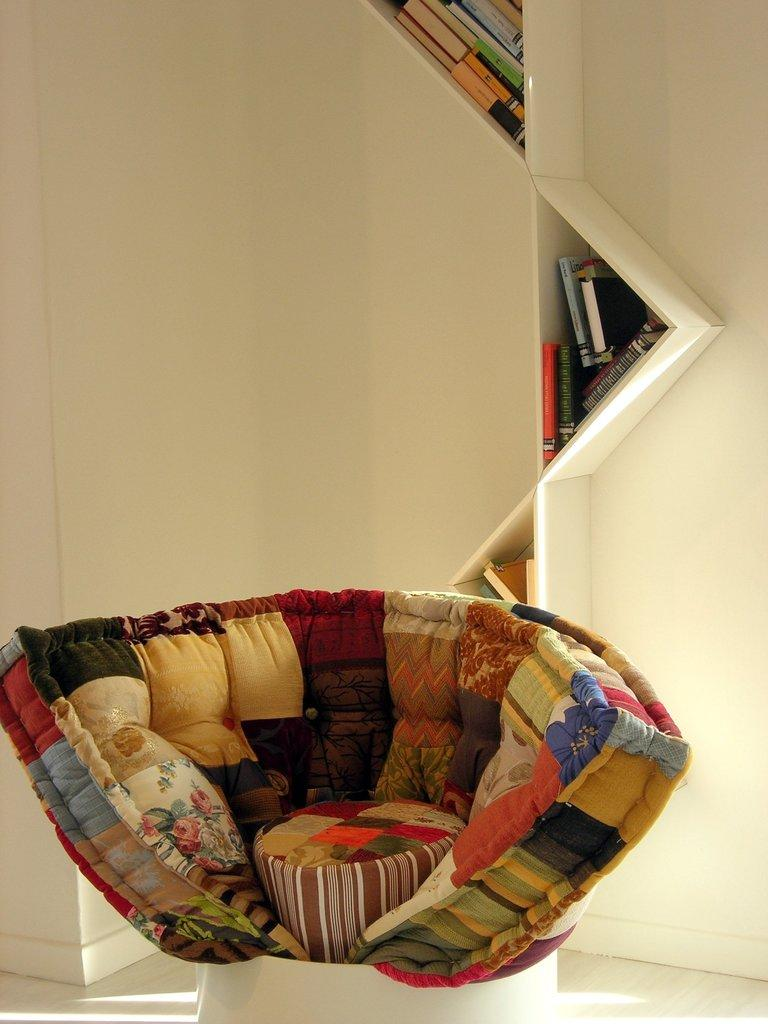What type of furniture is located in the front of the image? There is a sofa chair in the front of the image. What can be seen on the wall in the background of the image? There are books on wall shelves in the background of the image. What advice does the queen give to the mother in the town in the image? There is no queen, mother, or town present in the image; it only features a sofa chair and books on wall shelves. 